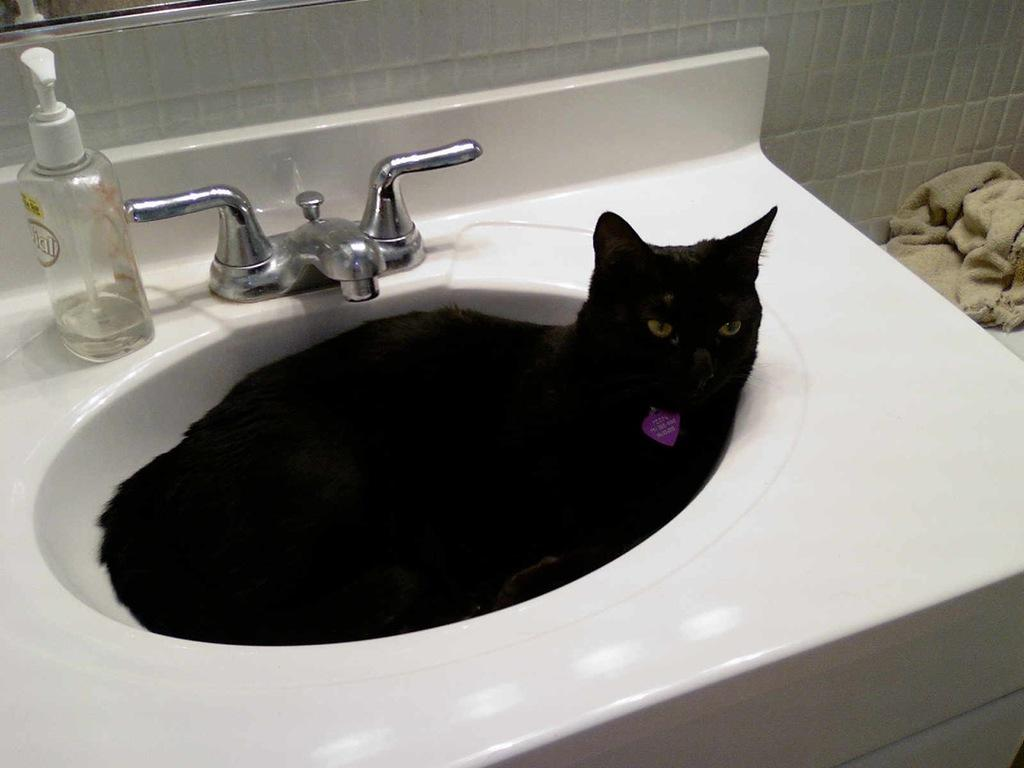What type of animal is in the image? There is a black cat in the image. Where is the cat located in the image? The cat is sleeping in a wash basin. What other objects can be seen in the image? There is a hand wash bottle, a cloth, and a tap in the image. Can you describe the location of the cloth in the image? The cloth is on the right side of the image. What type of amusement can be seen in the image? There is no amusement present in the image; it features a black cat sleeping in a wash basin and other objects. Is there a whip visible in the image? No, there is no whip present in the image. 